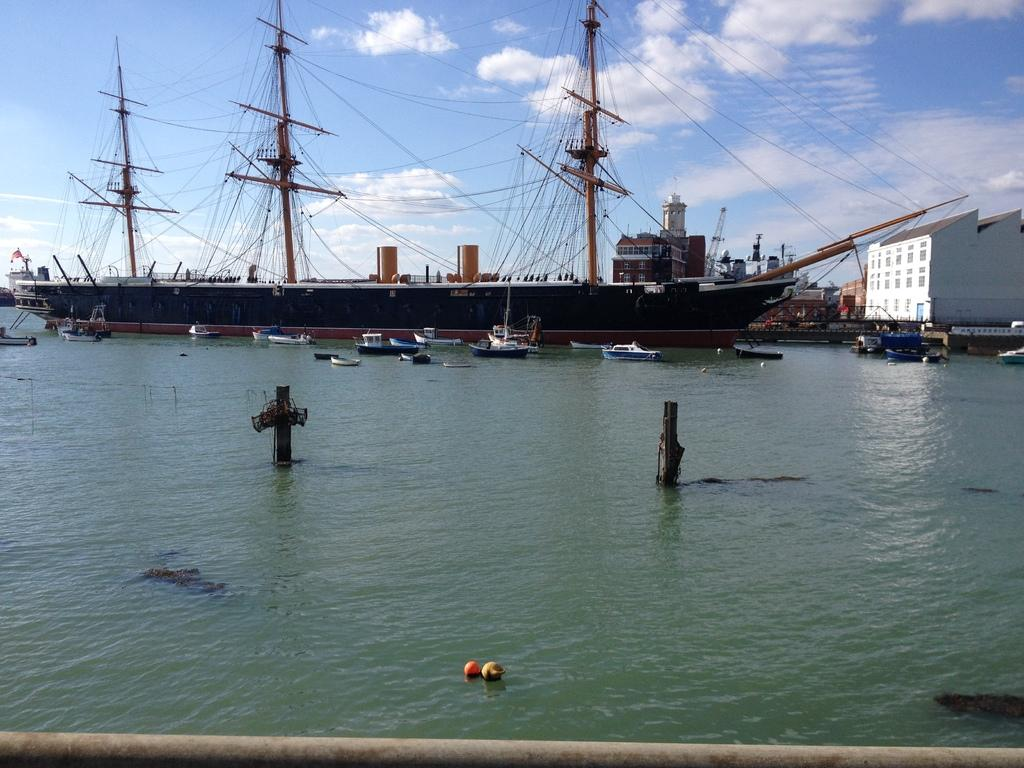What is the main subject of the image? The main subject of the image is many boats in the middle of the image. What is the setting of the image? The setting of the image includes water, buildings, and the sky in the background. Can you describe the boats in the background? Yes, there are boats in the background of the image. What is the condition of the sky in the image? The sky is visible in the background of the image, and clouds are present. What grade does the orange tree receive in the image? There is no orange tree present in the image, so it cannot receive a grade. 